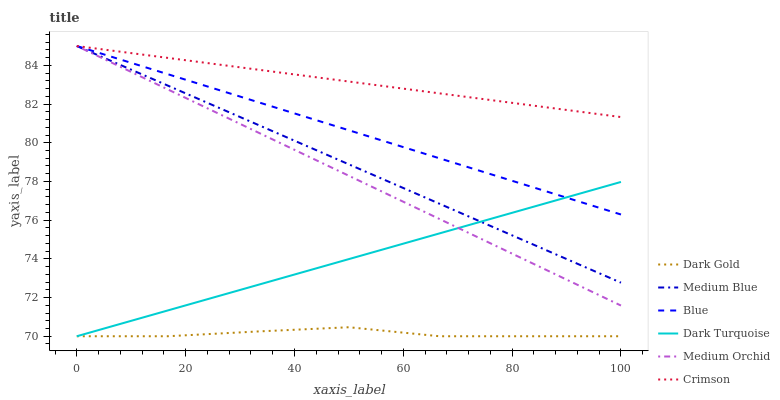Does Dark Gold have the minimum area under the curve?
Answer yes or no. Yes. Does Crimson have the maximum area under the curve?
Answer yes or no. Yes. Does Dark Turquoise have the minimum area under the curve?
Answer yes or no. No. Does Dark Turquoise have the maximum area under the curve?
Answer yes or no. No. Is Blue the smoothest?
Answer yes or no. Yes. Is Dark Gold the roughest?
Answer yes or no. Yes. Is Dark Turquoise the smoothest?
Answer yes or no. No. Is Dark Turquoise the roughest?
Answer yes or no. No. Does Dark Gold have the lowest value?
Answer yes or no. Yes. Does Medium Orchid have the lowest value?
Answer yes or no. No. Does Crimson have the highest value?
Answer yes or no. Yes. Does Dark Turquoise have the highest value?
Answer yes or no. No. Is Dark Turquoise less than Crimson?
Answer yes or no. Yes. Is Medium Orchid greater than Dark Gold?
Answer yes or no. Yes. Does Crimson intersect Medium Blue?
Answer yes or no. Yes. Is Crimson less than Medium Blue?
Answer yes or no. No. Is Crimson greater than Medium Blue?
Answer yes or no. No. Does Dark Turquoise intersect Crimson?
Answer yes or no. No. 